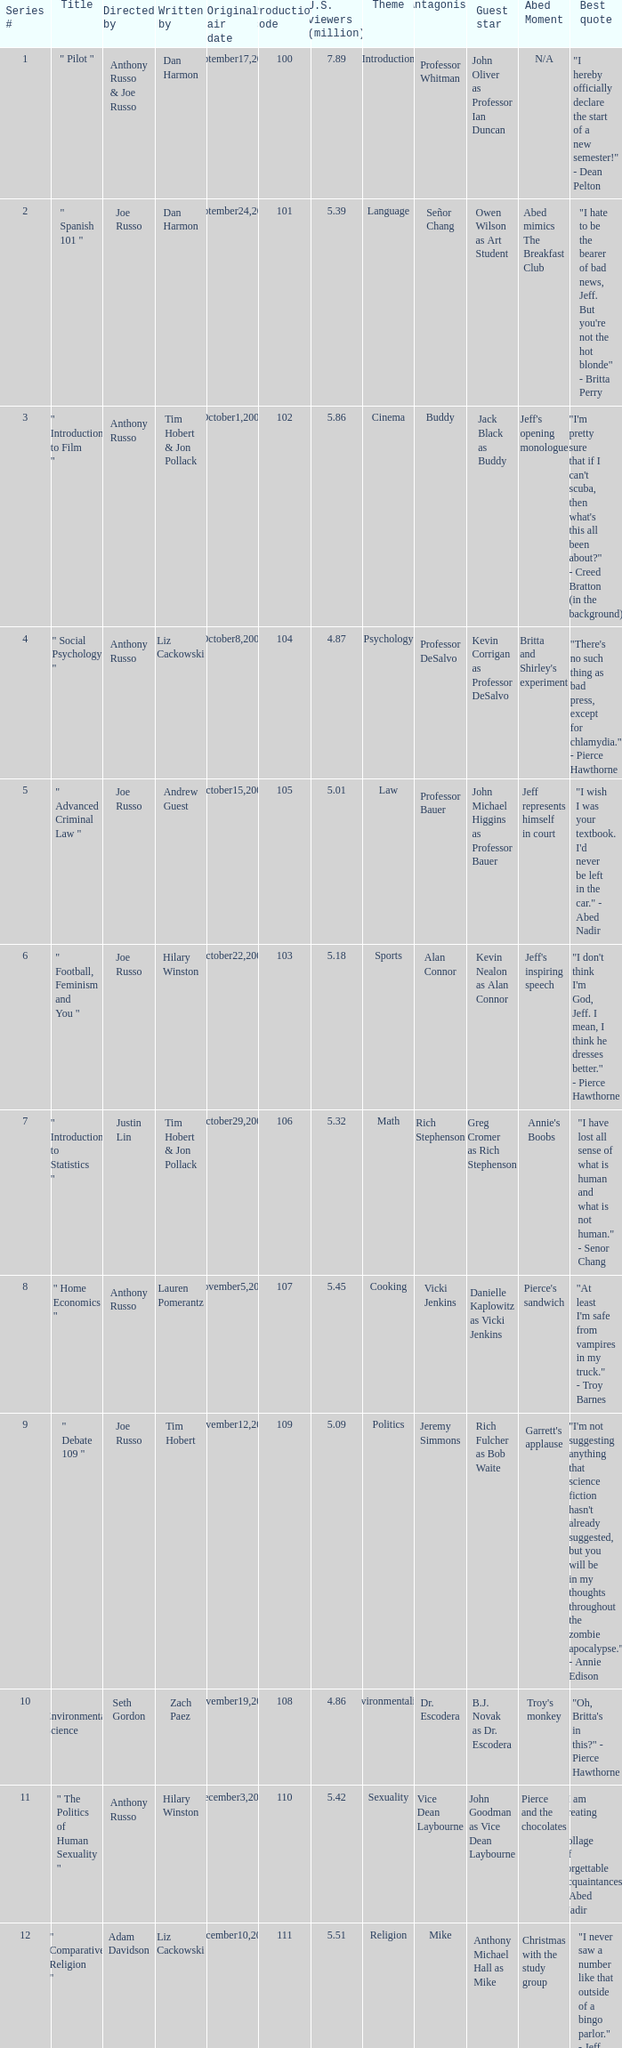What is the original air date when the u.s. viewers in millions was 5.39? September24,2009. 